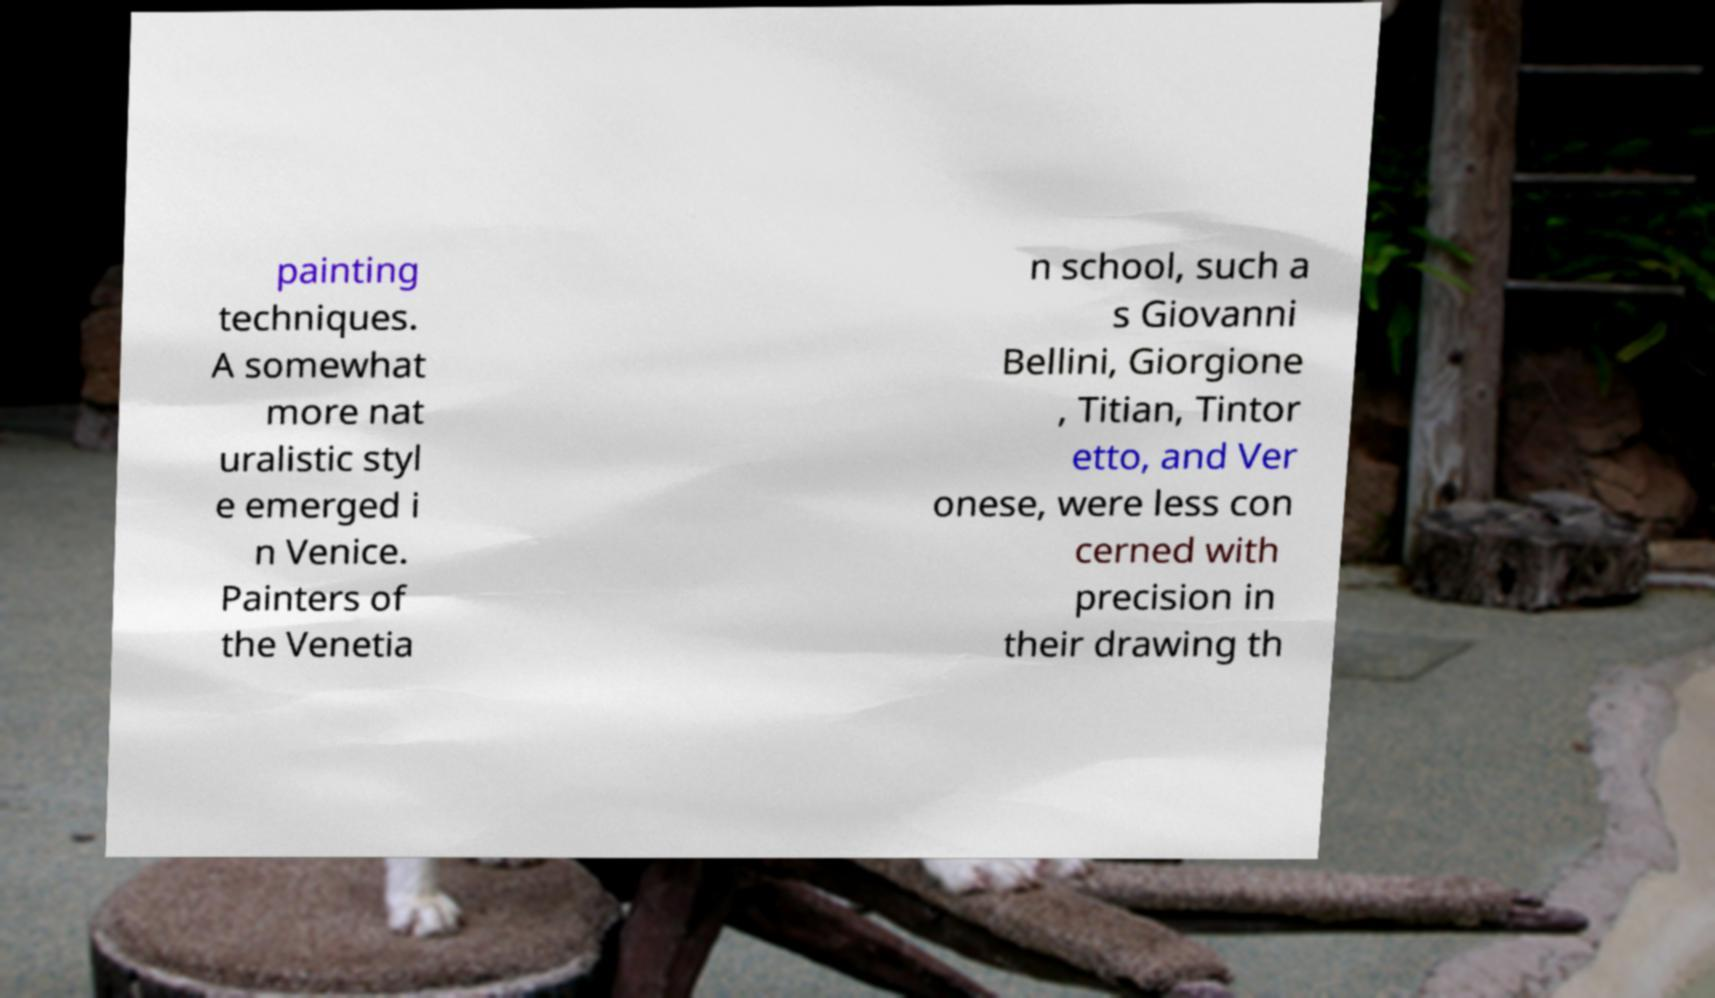Can you read and provide the text displayed in the image?This photo seems to have some interesting text. Can you extract and type it out for me? painting techniques. A somewhat more nat uralistic styl e emerged i n Venice. Painters of the Venetia n school, such a s Giovanni Bellini, Giorgione , Titian, Tintor etto, and Ver onese, were less con cerned with precision in their drawing th 